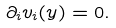<formula> <loc_0><loc_0><loc_500><loc_500>\partial _ { i } v _ { i } ( y ) = 0 .</formula> 